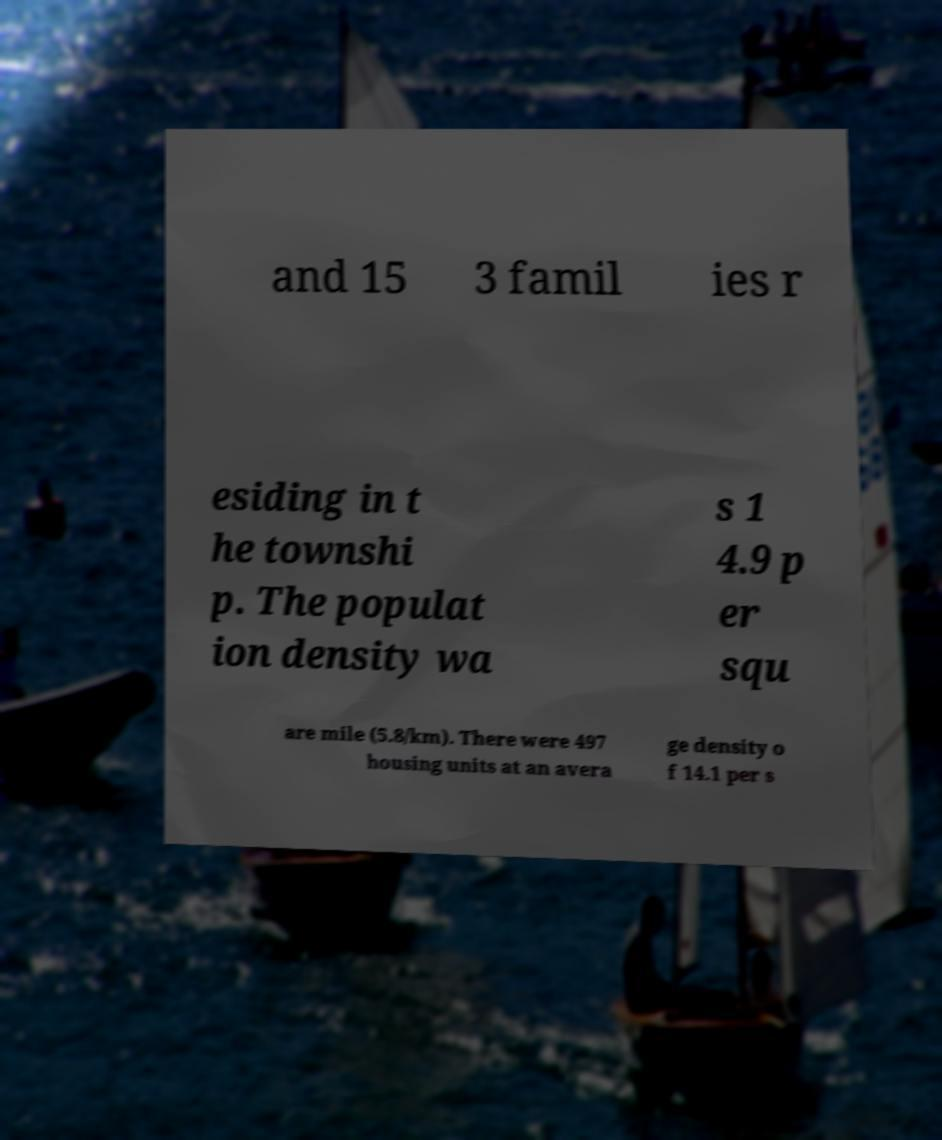Could you assist in decoding the text presented in this image and type it out clearly? and 15 3 famil ies r esiding in t he townshi p. The populat ion density wa s 1 4.9 p er squ are mile (5.8/km). There were 497 housing units at an avera ge density o f 14.1 per s 